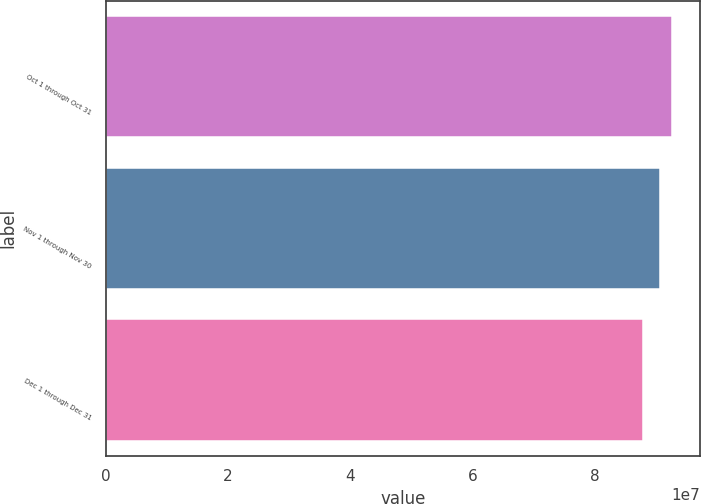<chart> <loc_0><loc_0><loc_500><loc_500><bar_chart><fcel>Oct 1 through Oct 31<fcel>Nov 1 through Nov 30<fcel>Dec 1 through Dec 31<nl><fcel>9.2618e+07<fcel>9.0743e+07<fcel>8.79566e+07<nl></chart> 